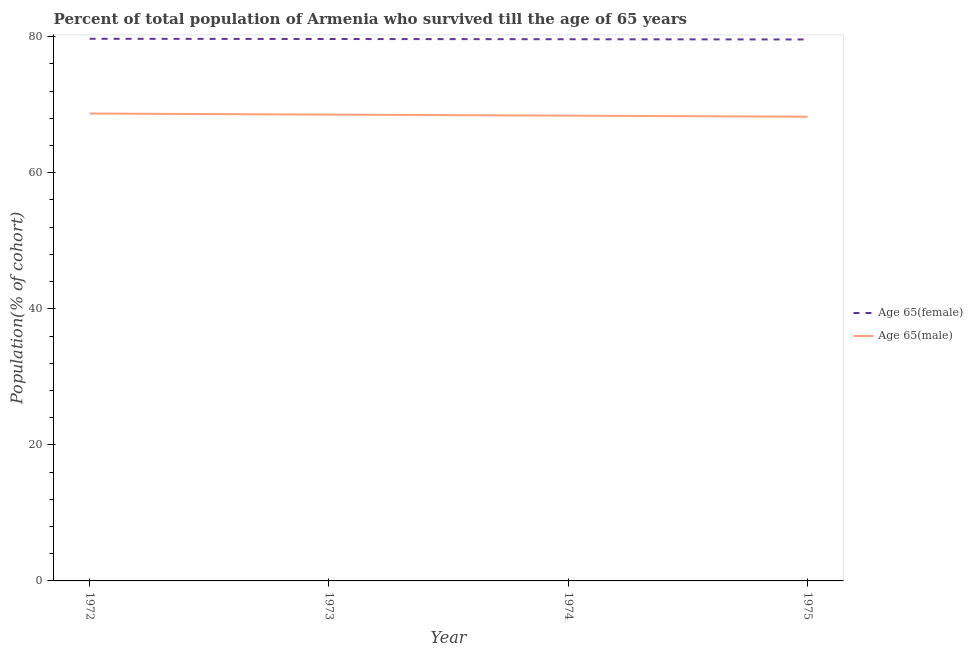How many different coloured lines are there?
Ensure brevity in your answer.  2. Does the line corresponding to percentage of female population who survived till age of 65 intersect with the line corresponding to percentage of male population who survived till age of 65?
Your response must be concise. No. Is the number of lines equal to the number of legend labels?
Offer a terse response. Yes. What is the percentage of male population who survived till age of 65 in 1973?
Give a very brief answer. 68.55. Across all years, what is the maximum percentage of female population who survived till age of 65?
Your answer should be very brief. 79.7. Across all years, what is the minimum percentage of female population who survived till age of 65?
Offer a very short reply. 79.6. In which year was the percentage of male population who survived till age of 65 maximum?
Your response must be concise. 1972. In which year was the percentage of male population who survived till age of 65 minimum?
Offer a very short reply. 1975. What is the total percentage of male population who survived till age of 65 in the graph?
Provide a succinct answer. 273.9. What is the difference between the percentage of male population who survived till age of 65 in 1972 and that in 1974?
Provide a succinct answer. 0.31. What is the difference between the percentage of female population who survived till age of 65 in 1972 and the percentage of male population who survived till age of 65 in 1975?
Provide a succinct answer. 11.46. What is the average percentage of female population who survived till age of 65 per year?
Ensure brevity in your answer.  79.65. In the year 1972, what is the difference between the percentage of female population who survived till age of 65 and percentage of male population who survived till age of 65?
Keep it short and to the point. 10.99. What is the ratio of the percentage of female population who survived till age of 65 in 1972 to that in 1975?
Your answer should be compact. 1. Is the percentage of male population who survived till age of 65 in 1972 less than that in 1973?
Provide a short and direct response. No. Is the difference between the percentage of male population who survived till age of 65 in 1973 and 1974 greater than the difference between the percentage of female population who survived till age of 65 in 1973 and 1974?
Offer a terse response. Yes. What is the difference between the highest and the second highest percentage of female population who survived till age of 65?
Provide a short and direct response. 0.03. What is the difference between the highest and the lowest percentage of female population who survived till age of 65?
Make the answer very short. 0.1. Is the sum of the percentage of male population who survived till age of 65 in 1972 and 1975 greater than the maximum percentage of female population who survived till age of 65 across all years?
Your answer should be very brief. Yes. Does the percentage of female population who survived till age of 65 monotonically increase over the years?
Your answer should be compact. No. Is the percentage of male population who survived till age of 65 strictly less than the percentage of female population who survived till age of 65 over the years?
Your answer should be very brief. Yes. How many years are there in the graph?
Provide a succinct answer. 4. What is the title of the graph?
Ensure brevity in your answer.  Percent of total population of Armenia who survived till the age of 65 years. What is the label or title of the X-axis?
Make the answer very short. Year. What is the label or title of the Y-axis?
Offer a terse response. Population(% of cohort). What is the Population(% of cohort) in Age 65(female) in 1972?
Offer a terse response. 79.7. What is the Population(% of cohort) of Age 65(male) in 1972?
Offer a very short reply. 68.71. What is the Population(% of cohort) in Age 65(female) in 1973?
Your answer should be very brief. 79.67. What is the Population(% of cohort) of Age 65(male) in 1973?
Your answer should be very brief. 68.55. What is the Population(% of cohort) of Age 65(female) in 1974?
Offer a terse response. 79.63. What is the Population(% of cohort) in Age 65(male) in 1974?
Give a very brief answer. 68.4. What is the Population(% of cohort) in Age 65(female) in 1975?
Provide a short and direct response. 79.6. What is the Population(% of cohort) of Age 65(male) in 1975?
Keep it short and to the point. 68.24. Across all years, what is the maximum Population(% of cohort) in Age 65(female)?
Your answer should be compact. 79.7. Across all years, what is the maximum Population(% of cohort) in Age 65(male)?
Make the answer very short. 68.71. Across all years, what is the minimum Population(% of cohort) of Age 65(female)?
Give a very brief answer. 79.6. Across all years, what is the minimum Population(% of cohort) of Age 65(male)?
Keep it short and to the point. 68.24. What is the total Population(% of cohort) of Age 65(female) in the graph?
Make the answer very short. 318.6. What is the total Population(% of cohort) of Age 65(male) in the graph?
Offer a terse response. 273.9. What is the difference between the Population(% of cohort) in Age 65(female) in 1972 and that in 1973?
Offer a very short reply. 0.03. What is the difference between the Population(% of cohort) in Age 65(male) in 1972 and that in 1973?
Offer a terse response. 0.16. What is the difference between the Population(% of cohort) of Age 65(female) in 1972 and that in 1974?
Your response must be concise. 0.07. What is the difference between the Population(% of cohort) of Age 65(male) in 1972 and that in 1974?
Keep it short and to the point. 0.31. What is the difference between the Population(% of cohort) in Age 65(female) in 1972 and that in 1975?
Make the answer very short. 0.1. What is the difference between the Population(% of cohort) in Age 65(male) in 1972 and that in 1975?
Keep it short and to the point. 0.47. What is the difference between the Population(% of cohort) in Age 65(female) in 1973 and that in 1974?
Provide a succinct answer. 0.03. What is the difference between the Population(% of cohort) of Age 65(male) in 1973 and that in 1974?
Offer a terse response. 0.16. What is the difference between the Population(% of cohort) of Age 65(female) in 1973 and that in 1975?
Keep it short and to the point. 0.07. What is the difference between the Population(% of cohort) in Age 65(male) in 1973 and that in 1975?
Give a very brief answer. 0.31. What is the difference between the Population(% of cohort) of Age 65(female) in 1974 and that in 1975?
Ensure brevity in your answer.  0.03. What is the difference between the Population(% of cohort) in Age 65(male) in 1974 and that in 1975?
Provide a short and direct response. 0.16. What is the difference between the Population(% of cohort) in Age 65(female) in 1972 and the Population(% of cohort) in Age 65(male) in 1973?
Provide a short and direct response. 11.15. What is the difference between the Population(% of cohort) in Age 65(female) in 1972 and the Population(% of cohort) in Age 65(male) in 1974?
Your answer should be compact. 11.3. What is the difference between the Population(% of cohort) of Age 65(female) in 1972 and the Population(% of cohort) of Age 65(male) in 1975?
Keep it short and to the point. 11.46. What is the difference between the Population(% of cohort) in Age 65(female) in 1973 and the Population(% of cohort) in Age 65(male) in 1974?
Offer a very short reply. 11.27. What is the difference between the Population(% of cohort) of Age 65(female) in 1973 and the Population(% of cohort) of Age 65(male) in 1975?
Provide a succinct answer. 11.42. What is the difference between the Population(% of cohort) in Age 65(female) in 1974 and the Population(% of cohort) in Age 65(male) in 1975?
Provide a succinct answer. 11.39. What is the average Population(% of cohort) of Age 65(female) per year?
Keep it short and to the point. 79.65. What is the average Population(% of cohort) of Age 65(male) per year?
Your response must be concise. 68.47. In the year 1972, what is the difference between the Population(% of cohort) in Age 65(female) and Population(% of cohort) in Age 65(male)?
Offer a very short reply. 10.99. In the year 1973, what is the difference between the Population(% of cohort) in Age 65(female) and Population(% of cohort) in Age 65(male)?
Offer a very short reply. 11.11. In the year 1974, what is the difference between the Population(% of cohort) of Age 65(female) and Population(% of cohort) of Age 65(male)?
Your answer should be compact. 11.24. In the year 1975, what is the difference between the Population(% of cohort) of Age 65(female) and Population(% of cohort) of Age 65(male)?
Your answer should be compact. 11.36. What is the ratio of the Population(% of cohort) in Age 65(male) in 1972 to that in 1973?
Offer a terse response. 1. What is the ratio of the Population(% of cohort) of Age 65(female) in 1972 to that in 1975?
Your answer should be compact. 1. What is the ratio of the Population(% of cohort) of Age 65(male) in 1972 to that in 1975?
Give a very brief answer. 1.01. What is the ratio of the Population(% of cohort) of Age 65(male) in 1973 to that in 1974?
Offer a terse response. 1. What is the ratio of the Population(% of cohort) of Age 65(female) in 1973 to that in 1975?
Provide a succinct answer. 1. What is the ratio of the Population(% of cohort) in Age 65(female) in 1974 to that in 1975?
Provide a succinct answer. 1. What is the difference between the highest and the second highest Population(% of cohort) of Age 65(female)?
Make the answer very short. 0.03. What is the difference between the highest and the second highest Population(% of cohort) in Age 65(male)?
Provide a short and direct response. 0.16. What is the difference between the highest and the lowest Population(% of cohort) of Age 65(female)?
Give a very brief answer. 0.1. What is the difference between the highest and the lowest Population(% of cohort) of Age 65(male)?
Offer a very short reply. 0.47. 